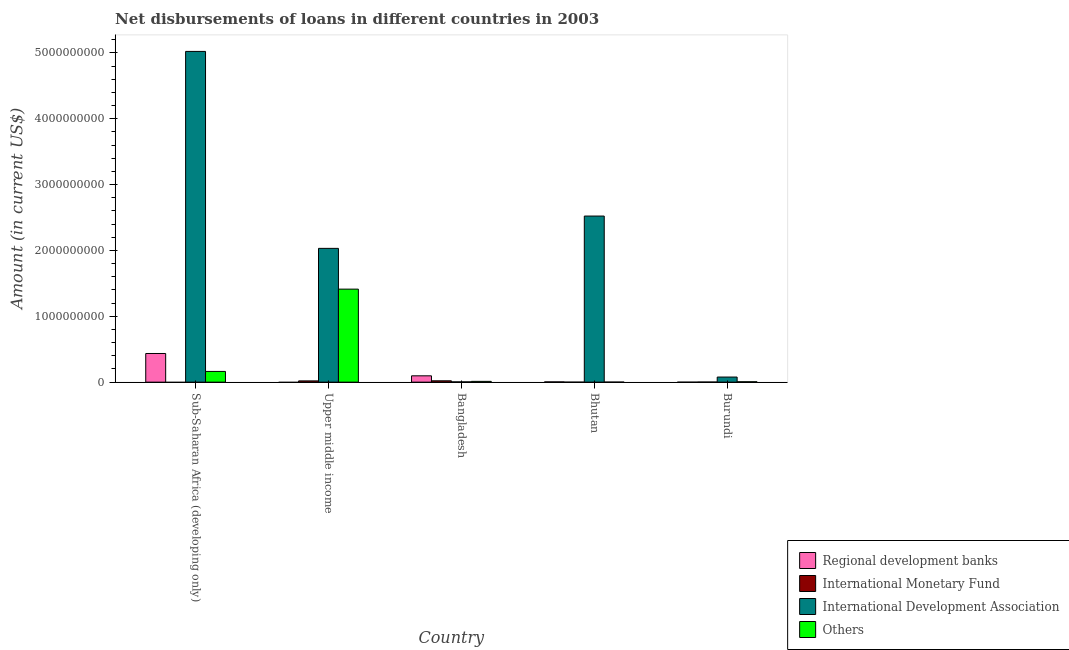How many different coloured bars are there?
Your response must be concise. 4. How many groups of bars are there?
Your answer should be very brief. 5. What is the label of the 2nd group of bars from the left?
Offer a very short reply. Upper middle income. In how many cases, is the number of bars for a given country not equal to the number of legend labels?
Your answer should be compact. 4. What is the amount of loan disimbursed by international development association in Bhutan?
Your response must be concise. 2.52e+09. Across all countries, what is the maximum amount of loan disimbursed by international development association?
Provide a short and direct response. 5.02e+09. Across all countries, what is the minimum amount of loan disimbursed by international development association?
Provide a succinct answer. 3.98e+06. In which country was the amount of loan disimbursed by international monetary fund maximum?
Provide a short and direct response. Bangladesh. What is the total amount of loan disimbursed by other organisations in the graph?
Your answer should be very brief. 1.59e+09. What is the difference between the amount of loan disimbursed by international development association in Bhutan and that in Upper middle income?
Keep it short and to the point. 4.91e+08. What is the difference between the amount of loan disimbursed by international monetary fund in Burundi and the amount of loan disimbursed by other organisations in Sub-Saharan Africa (developing only)?
Give a very brief answer. -1.61e+08. What is the average amount of loan disimbursed by international development association per country?
Offer a very short reply. 1.93e+09. What is the difference between the amount of loan disimbursed by international development association and amount of loan disimbursed by regional development banks in Bhutan?
Give a very brief answer. 2.52e+09. What is the ratio of the amount of loan disimbursed by other organisations in Bangladesh to that in Burundi?
Provide a short and direct response. 2.03. What is the difference between the highest and the second highest amount of loan disimbursed by other organisations?
Provide a succinct answer. 1.25e+09. What is the difference between the highest and the lowest amount of loan disimbursed by international development association?
Make the answer very short. 5.02e+09. In how many countries, is the amount of loan disimbursed by international development association greater than the average amount of loan disimbursed by international development association taken over all countries?
Provide a succinct answer. 3. Is the sum of the amount of loan disimbursed by international development association in Bhutan and Burundi greater than the maximum amount of loan disimbursed by regional development banks across all countries?
Provide a succinct answer. Yes. Is it the case that in every country, the sum of the amount of loan disimbursed by international monetary fund and amount of loan disimbursed by regional development banks is greater than the sum of amount of loan disimbursed by other organisations and amount of loan disimbursed by international development association?
Your answer should be very brief. No. How many countries are there in the graph?
Make the answer very short. 5. What is the difference between two consecutive major ticks on the Y-axis?
Ensure brevity in your answer.  1.00e+09. Are the values on the major ticks of Y-axis written in scientific E-notation?
Offer a terse response. No. Does the graph contain grids?
Make the answer very short. No. Where does the legend appear in the graph?
Offer a very short reply. Bottom right. What is the title of the graph?
Offer a very short reply. Net disbursements of loans in different countries in 2003. Does "Secondary general education" appear as one of the legend labels in the graph?
Make the answer very short. No. What is the label or title of the X-axis?
Make the answer very short. Country. What is the Amount (in current US$) in Regional development banks in Sub-Saharan Africa (developing only)?
Your answer should be very brief. 4.35e+08. What is the Amount (in current US$) of International Monetary Fund in Sub-Saharan Africa (developing only)?
Give a very brief answer. 0. What is the Amount (in current US$) in International Development Association in Sub-Saharan Africa (developing only)?
Provide a succinct answer. 5.02e+09. What is the Amount (in current US$) in Others in Sub-Saharan Africa (developing only)?
Your response must be concise. 1.63e+08. What is the Amount (in current US$) of Regional development banks in Upper middle income?
Give a very brief answer. 0. What is the Amount (in current US$) of International Monetary Fund in Upper middle income?
Your answer should be compact. 1.91e+07. What is the Amount (in current US$) of International Development Association in Upper middle income?
Ensure brevity in your answer.  2.03e+09. What is the Amount (in current US$) in Others in Upper middle income?
Give a very brief answer. 1.41e+09. What is the Amount (in current US$) in Regional development banks in Bangladesh?
Ensure brevity in your answer.  9.61e+07. What is the Amount (in current US$) in International Monetary Fund in Bangladesh?
Make the answer very short. 2.05e+07. What is the Amount (in current US$) of International Development Association in Bangladesh?
Offer a very short reply. 3.98e+06. What is the Amount (in current US$) of Others in Bangladesh?
Ensure brevity in your answer.  1.18e+07. What is the Amount (in current US$) in Regional development banks in Bhutan?
Your response must be concise. 4.04e+06. What is the Amount (in current US$) of International Development Association in Bhutan?
Give a very brief answer. 2.52e+09. What is the Amount (in current US$) in Others in Bhutan?
Offer a terse response. 7.45e+05. What is the Amount (in current US$) of International Monetary Fund in Burundi?
Your answer should be very brief. 1.43e+06. What is the Amount (in current US$) of International Development Association in Burundi?
Provide a succinct answer. 7.74e+07. What is the Amount (in current US$) of Others in Burundi?
Make the answer very short. 5.82e+06. Across all countries, what is the maximum Amount (in current US$) in Regional development banks?
Give a very brief answer. 4.35e+08. Across all countries, what is the maximum Amount (in current US$) in International Monetary Fund?
Your response must be concise. 2.05e+07. Across all countries, what is the maximum Amount (in current US$) of International Development Association?
Offer a very short reply. 5.02e+09. Across all countries, what is the maximum Amount (in current US$) of Others?
Make the answer very short. 1.41e+09. Across all countries, what is the minimum Amount (in current US$) in Regional development banks?
Give a very brief answer. 0. Across all countries, what is the minimum Amount (in current US$) in International Development Association?
Keep it short and to the point. 3.98e+06. Across all countries, what is the minimum Amount (in current US$) of Others?
Provide a short and direct response. 7.45e+05. What is the total Amount (in current US$) of Regional development banks in the graph?
Provide a succinct answer. 5.35e+08. What is the total Amount (in current US$) in International Monetary Fund in the graph?
Your answer should be very brief. 4.10e+07. What is the total Amount (in current US$) of International Development Association in the graph?
Keep it short and to the point. 9.66e+09. What is the total Amount (in current US$) of Others in the graph?
Make the answer very short. 1.59e+09. What is the difference between the Amount (in current US$) in International Development Association in Sub-Saharan Africa (developing only) and that in Upper middle income?
Your answer should be very brief. 2.99e+09. What is the difference between the Amount (in current US$) in Others in Sub-Saharan Africa (developing only) and that in Upper middle income?
Your answer should be compact. -1.25e+09. What is the difference between the Amount (in current US$) of Regional development banks in Sub-Saharan Africa (developing only) and that in Bangladesh?
Make the answer very short. 3.39e+08. What is the difference between the Amount (in current US$) of International Development Association in Sub-Saharan Africa (developing only) and that in Bangladesh?
Ensure brevity in your answer.  5.02e+09. What is the difference between the Amount (in current US$) in Others in Sub-Saharan Africa (developing only) and that in Bangladesh?
Provide a succinct answer. 1.51e+08. What is the difference between the Amount (in current US$) in Regional development banks in Sub-Saharan Africa (developing only) and that in Bhutan?
Offer a terse response. 4.31e+08. What is the difference between the Amount (in current US$) in International Development Association in Sub-Saharan Africa (developing only) and that in Bhutan?
Your answer should be very brief. 2.50e+09. What is the difference between the Amount (in current US$) of Others in Sub-Saharan Africa (developing only) and that in Bhutan?
Ensure brevity in your answer.  1.62e+08. What is the difference between the Amount (in current US$) of International Development Association in Sub-Saharan Africa (developing only) and that in Burundi?
Offer a terse response. 4.95e+09. What is the difference between the Amount (in current US$) of Others in Sub-Saharan Africa (developing only) and that in Burundi?
Offer a terse response. 1.57e+08. What is the difference between the Amount (in current US$) of International Monetary Fund in Upper middle income and that in Bangladesh?
Offer a terse response. -1.38e+06. What is the difference between the Amount (in current US$) in International Development Association in Upper middle income and that in Bangladesh?
Give a very brief answer. 2.03e+09. What is the difference between the Amount (in current US$) in Others in Upper middle income and that in Bangladesh?
Provide a succinct answer. 1.40e+09. What is the difference between the Amount (in current US$) in International Development Association in Upper middle income and that in Bhutan?
Ensure brevity in your answer.  -4.91e+08. What is the difference between the Amount (in current US$) in Others in Upper middle income and that in Bhutan?
Make the answer very short. 1.41e+09. What is the difference between the Amount (in current US$) of International Monetary Fund in Upper middle income and that in Burundi?
Your answer should be compact. 1.76e+07. What is the difference between the Amount (in current US$) of International Development Association in Upper middle income and that in Burundi?
Keep it short and to the point. 1.95e+09. What is the difference between the Amount (in current US$) of Others in Upper middle income and that in Burundi?
Your answer should be compact. 1.41e+09. What is the difference between the Amount (in current US$) in Regional development banks in Bangladesh and that in Bhutan?
Provide a succinct answer. 9.21e+07. What is the difference between the Amount (in current US$) in International Development Association in Bangladesh and that in Bhutan?
Provide a succinct answer. -2.52e+09. What is the difference between the Amount (in current US$) in Others in Bangladesh and that in Bhutan?
Offer a terse response. 1.11e+07. What is the difference between the Amount (in current US$) of International Monetary Fund in Bangladesh and that in Burundi?
Your response must be concise. 1.90e+07. What is the difference between the Amount (in current US$) of International Development Association in Bangladesh and that in Burundi?
Keep it short and to the point. -7.34e+07. What is the difference between the Amount (in current US$) of Others in Bangladesh and that in Burundi?
Keep it short and to the point. 6.02e+06. What is the difference between the Amount (in current US$) of International Development Association in Bhutan and that in Burundi?
Provide a succinct answer. 2.45e+09. What is the difference between the Amount (in current US$) in Others in Bhutan and that in Burundi?
Offer a very short reply. -5.08e+06. What is the difference between the Amount (in current US$) of Regional development banks in Sub-Saharan Africa (developing only) and the Amount (in current US$) of International Monetary Fund in Upper middle income?
Your response must be concise. 4.16e+08. What is the difference between the Amount (in current US$) of Regional development banks in Sub-Saharan Africa (developing only) and the Amount (in current US$) of International Development Association in Upper middle income?
Keep it short and to the point. -1.60e+09. What is the difference between the Amount (in current US$) of Regional development banks in Sub-Saharan Africa (developing only) and the Amount (in current US$) of Others in Upper middle income?
Your response must be concise. -9.77e+08. What is the difference between the Amount (in current US$) of International Development Association in Sub-Saharan Africa (developing only) and the Amount (in current US$) of Others in Upper middle income?
Ensure brevity in your answer.  3.61e+09. What is the difference between the Amount (in current US$) of Regional development banks in Sub-Saharan Africa (developing only) and the Amount (in current US$) of International Monetary Fund in Bangladesh?
Provide a short and direct response. 4.15e+08. What is the difference between the Amount (in current US$) of Regional development banks in Sub-Saharan Africa (developing only) and the Amount (in current US$) of International Development Association in Bangladesh?
Provide a short and direct response. 4.31e+08. What is the difference between the Amount (in current US$) of Regional development banks in Sub-Saharan Africa (developing only) and the Amount (in current US$) of Others in Bangladesh?
Ensure brevity in your answer.  4.23e+08. What is the difference between the Amount (in current US$) of International Development Association in Sub-Saharan Africa (developing only) and the Amount (in current US$) of Others in Bangladesh?
Provide a succinct answer. 5.01e+09. What is the difference between the Amount (in current US$) of Regional development banks in Sub-Saharan Africa (developing only) and the Amount (in current US$) of International Development Association in Bhutan?
Offer a very short reply. -2.09e+09. What is the difference between the Amount (in current US$) of Regional development banks in Sub-Saharan Africa (developing only) and the Amount (in current US$) of Others in Bhutan?
Offer a very short reply. 4.35e+08. What is the difference between the Amount (in current US$) of International Development Association in Sub-Saharan Africa (developing only) and the Amount (in current US$) of Others in Bhutan?
Give a very brief answer. 5.02e+09. What is the difference between the Amount (in current US$) in Regional development banks in Sub-Saharan Africa (developing only) and the Amount (in current US$) in International Monetary Fund in Burundi?
Offer a terse response. 4.34e+08. What is the difference between the Amount (in current US$) of Regional development banks in Sub-Saharan Africa (developing only) and the Amount (in current US$) of International Development Association in Burundi?
Offer a very short reply. 3.58e+08. What is the difference between the Amount (in current US$) in Regional development banks in Sub-Saharan Africa (developing only) and the Amount (in current US$) in Others in Burundi?
Your response must be concise. 4.29e+08. What is the difference between the Amount (in current US$) in International Development Association in Sub-Saharan Africa (developing only) and the Amount (in current US$) in Others in Burundi?
Make the answer very short. 5.02e+09. What is the difference between the Amount (in current US$) in International Monetary Fund in Upper middle income and the Amount (in current US$) in International Development Association in Bangladesh?
Offer a terse response. 1.51e+07. What is the difference between the Amount (in current US$) in International Monetary Fund in Upper middle income and the Amount (in current US$) in Others in Bangladesh?
Ensure brevity in your answer.  7.23e+06. What is the difference between the Amount (in current US$) of International Development Association in Upper middle income and the Amount (in current US$) of Others in Bangladesh?
Your answer should be very brief. 2.02e+09. What is the difference between the Amount (in current US$) in International Monetary Fund in Upper middle income and the Amount (in current US$) in International Development Association in Bhutan?
Keep it short and to the point. -2.50e+09. What is the difference between the Amount (in current US$) of International Monetary Fund in Upper middle income and the Amount (in current US$) of Others in Bhutan?
Offer a very short reply. 1.83e+07. What is the difference between the Amount (in current US$) in International Development Association in Upper middle income and the Amount (in current US$) in Others in Bhutan?
Keep it short and to the point. 2.03e+09. What is the difference between the Amount (in current US$) of International Monetary Fund in Upper middle income and the Amount (in current US$) of International Development Association in Burundi?
Ensure brevity in your answer.  -5.83e+07. What is the difference between the Amount (in current US$) of International Monetary Fund in Upper middle income and the Amount (in current US$) of Others in Burundi?
Your answer should be compact. 1.33e+07. What is the difference between the Amount (in current US$) of International Development Association in Upper middle income and the Amount (in current US$) of Others in Burundi?
Your answer should be compact. 2.03e+09. What is the difference between the Amount (in current US$) in Regional development banks in Bangladesh and the Amount (in current US$) in International Development Association in Bhutan?
Your answer should be compact. -2.43e+09. What is the difference between the Amount (in current US$) of Regional development banks in Bangladesh and the Amount (in current US$) of Others in Bhutan?
Provide a succinct answer. 9.54e+07. What is the difference between the Amount (in current US$) of International Monetary Fund in Bangladesh and the Amount (in current US$) of International Development Association in Bhutan?
Make the answer very short. -2.50e+09. What is the difference between the Amount (in current US$) in International Monetary Fund in Bangladesh and the Amount (in current US$) in Others in Bhutan?
Provide a short and direct response. 1.97e+07. What is the difference between the Amount (in current US$) in International Development Association in Bangladesh and the Amount (in current US$) in Others in Bhutan?
Your answer should be very brief. 3.24e+06. What is the difference between the Amount (in current US$) of Regional development banks in Bangladesh and the Amount (in current US$) of International Monetary Fund in Burundi?
Your answer should be very brief. 9.47e+07. What is the difference between the Amount (in current US$) in Regional development banks in Bangladesh and the Amount (in current US$) in International Development Association in Burundi?
Keep it short and to the point. 1.88e+07. What is the difference between the Amount (in current US$) of Regional development banks in Bangladesh and the Amount (in current US$) of Others in Burundi?
Offer a very short reply. 9.03e+07. What is the difference between the Amount (in current US$) of International Monetary Fund in Bangladesh and the Amount (in current US$) of International Development Association in Burundi?
Provide a short and direct response. -5.69e+07. What is the difference between the Amount (in current US$) in International Monetary Fund in Bangladesh and the Amount (in current US$) in Others in Burundi?
Offer a terse response. 1.46e+07. What is the difference between the Amount (in current US$) in International Development Association in Bangladesh and the Amount (in current US$) in Others in Burundi?
Your response must be concise. -1.84e+06. What is the difference between the Amount (in current US$) of Regional development banks in Bhutan and the Amount (in current US$) of International Monetary Fund in Burundi?
Ensure brevity in your answer.  2.61e+06. What is the difference between the Amount (in current US$) of Regional development banks in Bhutan and the Amount (in current US$) of International Development Association in Burundi?
Offer a very short reply. -7.33e+07. What is the difference between the Amount (in current US$) in Regional development banks in Bhutan and the Amount (in current US$) in Others in Burundi?
Your response must be concise. -1.78e+06. What is the difference between the Amount (in current US$) in International Development Association in Bhutan and the Amount (in current US$) in Others in Burundi?
Offer a very short reply. 2.52e+09. What is the average Amount (in current US$) of Regional development banks per country?
Your answer should be very brief. 1.07e+08. What is the average Amount (in current US$) of International Monetary Fund per country?
Offer a very short reply. 8.19e+06. What is the average Amount (in current US$) in International Development Association per country?
Your answer should be compact. 1.93e+09. What is the average Amount (in current US$) in Others per country?
Give a very brief answer. 3.19e+08. What is the difference between the Amount (in current US$) in Regional development banks and Amount (in current US$) in International Development Association in Sub-Saharan Africa (developing only)?
Your answer should be compact. -4.59e+09. What is the difference between the Amount (in current US$) of Regional development banks and Amount (in current US$) of Others in Sub-Saharan Africa (developing only)?
Offer a very short reply. 2.73e+08. What is the difference between the Amount (in current US$) in International Development Association and Amount (in current US$) in Others in Sub-Saharan Africa (developing only)?
Your answer should be very brief. 4.86e+09. What is the difference between the Amount (in current US$) of International Monetary Fund and Amount (in current US$) of International Development Association in Upper middle income?
Provide a short and direct response. -2.01e+09. What is the difference between the Amount (in current US$) of International Monetary Fund and Amount (in current US$) of Others in Upper middle income?
Offer a terse response. -1.39e+09. What is the difference between the Amount (in current US$) of International Development Association and Amount (in current US$) of Others in Upper middle income?
Offer a terse response. 6.19e+08. What is the difference between the Amount (in current US$) of Regional development banks and Amount (in current US$) of International Monetary Fund in Bangladesh?
Your answer should be very brief. 7.57e+07. What is the difference between the Amount (in current US$) of Regional development banks and Amount (in current US$) of International Development Association in Bangladesh?
Your response must be concise. 9.22e+07. What is the difference between the Amount (in current US$) of Regional development banks and Amount (in current US$) of Others in Bangladesh?
Offer a very short reply. 8.43e+07. What is the difference between the Amount (in current US$) in International Monetary Fund and Amount (in current US$) in International Development Association in Bangladesh?
Offer a terse response. 1.65e+07. What is the difference between the Amount (in current US$) of International Monetary Fund and Amount (in current US$) of Others in Bangladesh?
Give a very brief answer. 8.62e+06. What is the difference between the Amount (in current US$) in International Development Association and Amount (in current US$) in Others in Bangladesh?
Provide a succinct answer. -7.86e+06. What is the difference between the Amount (in current US$) of Regional development banks and Amount (in current US$) of International Development Association in Bhutan?
Keep it short and to the point. -2.52e+09. What is the difference between the Amount (in current US$) in Regional development banks and Amount (in current US$) in Others in Bhutan?
Ensure brevity in your answer.  3.30e+06. What is the difference between the Amount (in current US$) in International Development Association and Amount (in current US$) in Others in Bhutan?
Offer a terse response. 2.52e+09. What is the difference between the Amount (in current US$) in International Monetary Fund and Amount (in current US$) in International Development Association in Burundi?
Ensure brevity in your answer.  -7.60e+07. What is the difference between the Amount (in current US$) in International Monetary Fund and Amount (in current US$) in Others in Burundi?
Offer a very short reply. -4.39e+06. What is the difference between the Amount (in current US$) in International Development Association and Amount (in current US$) in Others in Burundi?
Ensure brevity in your answer.  7.16e+07. What is the ratio of the Amount (in current US$) in International Development Association in Sub-Saharan Africa (developing only) to that in Upper middle income?
Offer a very short reply. 2.47. What is the ratio of the Amount (in current US$) in Others in Sub-Saharan Africa (developing only) to that in Upper middle income?
Your answer should be very brief. 0.12. What is the ratio of the Amount (in current US$) of Regional development banks in Sub-Saharan Africa (developing only) to that in Bangladesh?
Provide a short and direct response. 4.53. What is the ratio of the Amount (in current US$) of International Development Association in Sub-Saharan Africa (developing only) to that in Bangladesh?
Provide a succinct answer. 1261.78. What is the ratio of the Amount (in current US$) in Others in Sub-Saharan Africa (developing only) to that in Bangladesh?
Provide a short and direct response. 13.75. What is the ratio of the Amount (in current US$) in Regional development banks in Sub-Saharan Africa (developing only) to that in Bhutan?
Your answer should be very brief. 107.74. What is the ratio of the Amount (in current US$) in International Development Association in Sub-Saharan Africa (developing only) to that in Bhutan?
Ensure brevity in your answer.  1.99. What is the ratio of the Amount (in current US$) of Others in Sub-Saharan Africa (developing only) to that in Bhutan?
Provide a succinct answer. 218.46. What is the ratio of the Amount (in current US$) of International Development Association in Sub-Saharan Africa (developing only) to that in Burundi?
Keep it short and to the point. 64.91. What is the ratio of the Amount (in current US$) of Others in Sub-Saharan Africa (developing only) to that in Burundi?
Give a very brief answer. 27.96. What is the ratio of the Amount (in current US$) in International Monetary Fund in Upper middle income to that in Bangladesh?
Keep it short and to the point. 0.93. What is the ratio of the Amount (in current US$) of International Development Association in Upper middle income to that in Bangladesh?
Give a very brief answer. 510.38. What is the ratio of the Amount (in current US$) of Others in Upper middle income to that in Bangladesh?
Keep it short and to the point. 119.32. What is the ratio of the Amount (in current US$) of International Development Association in Upper middle income to that in Bhutan?
Keep it short and to the point. 0.81. What is the ratio of the Amount (in current US$) in Others in Upper middle income to that in Bhutan?
Provide a succinct answer. 1896.17. What is the ratio of the Amount (in current US$) of International Monetary Fund in Upper middle income to that in Burundi?
Offer a very short reply. 13.31. What is the ratio of the Amount (in current US$) of International Development Association in Upper middle income to that in Burundi?
Your answer should be compact. 26.26. What is the ratio of the Amount (in current US$) in Others in Upper middle income to that in Burundi?
Give a very brief answer. 242.72. What is the ratio of the Amount (in current US$) in Regional development banks in Bangladesh to that in Bhutan?
Provide a succinct answer. 23.8. What is the ratio of the Amount (in current US$) in International Development Association in Bangladesh to that in Bhutan?
Keep it short and to the point. 0. What is the ratio of the Amount (in current US$) in Others in Bangladesh to that in Bhutan?
Keep it short and to the point. 15.89. What is the ratio of the Amount (in current US$) of International Monetary Fund in Bangladesh to that in Burundi?
Give a very brief answer. 14.27. What is the ratio of the Amount (in current US$) of International Development Association in Bangladesh to that in Burundi?
Make the answer very short. 0.05. What is the ratio of the Amount (in current US$) of Others in Bangladesh to that in Burundi?
Provide a short and direct response. 2.03. What is the ratio of the Amount (in current US$) in International Development Association in Bhutan to that in Burundi?
Ensure brevity in your answer.  32.6. What is the ratio of the Amount (in current US$) of Others in Bhutan to that in Burundi?
Your answer should be compact. 0.13. What is the difference between the highest and the second highest Amount (in current US$) in Regional development banks?
Provide a succinct answer. 3.39e+08. What is the difference between the highest and the second highest Amount (in current US$) in International Monetary Fund?
Ensure brevity in your answer.  1.38e+06. What is the difference between the highest and the second highest Amount (in current US$) of International Development Association?
Offer a very short reply. 2.50e+09. What is the difference between the highest and the second highest Amount (in current US$) of Others?
Provide a succinct answer. 1.25e+09. What is the difference between the highest and the lowest Amount (in current US$) of Regional development banks?
Provide a short and direct response. 4.35e+08. What is the difference between the highest and the lowest Amount (in current US$) of International Monetary Fund?
Ensure brevity in your answer.  2.05e+07. What is the difference between the highest and the lowest Amount (in current US$) in International Development Association?
Your answer should be compact. 5.02e+09. What is the difference between the highest and the lowest Amount (in current US$) of Others?
Offer a terse response. 1.41e+09. 